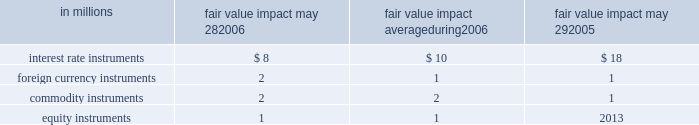Item 7a quantitative and qualitative disclosures about market risk we are exposed to market risk stemming from changes in interest rates , foreign exchange rates , commodity prices and equity prices .
Changes in these factors could cause fluctuations in our earnings and cash flows .
In the normal course of business , we actively manage our exposure to these market risks by entering into various hedging trans- actions , authorized under our policies that place clear controls on these activities .
The counterparties in these transactions are generally highly rated institutions .
We establish credit limits for each counterparty .
Our hedging transactions include but are not limited to a variety of deriv- ative financial instruments .
Interest rates we manage our debt structure and our interest rate risk through the use of fixed- and floating-rate debt and derivatives .
We use interest rate swaps and forward-starting interest rate swaps to hedge our exposure to interest rate changes and to reduce volatility of our financing costs .
Generally under these swaps , we agree with a counterparty to exchange the difference between fixed- rate and floating-rate interest amounts based on an agreed notional principal amount .
Our primary exposure is to u.s .
Interest rates .
As of may 28 , 2006 , we had $ 7.0 billion of aggregate notional principal amount ( the principal amount on which the fixed or floating interest rate is calculated ) outstanding .
This includes notional amounts of offsetting swaps that neutralize our exposure to interest rates on other interest rate swaps .
See note six to the consolidated finan- cial statements on pages 40 through 42 in item eight of this report .
Foreign currency rates foreign currency fluctuations can affect our net investments and earnings denominated in foreign currencies .
We primarily use foreign currency forward contracts and option contracts to selectively hedge our cash flow exposure to changes in exchange rates .
These contracts function as hedges , since they change in value inversely to the change created in the underlying exposure as foreign exchange rates fluctuate .
Our primary u.s .
Dollar exchange rate exposures are with the canadian dollar , the euro , the australian dollar , the mexican peso and the british pound .
Commodities many commodities we use in the produc- tion and distribution of our products are exposed to market price risks .
We manage this market risk through an inte- grated set of financial instruments , including purchase orders , noncancelable contracts , futures contracts , options and swaps .
Our primary commodity price exposures are to cereal grains , sugar , dairy products , vegetables , fruits , meats , vegetable oils , and other agricultural products , as well as paper and plastic packaging materials , operating supplies and energy .
Equity instruments equity price movements affect our compensation expense as certain investments owned by our employees are revalued .
We use equity swaps to manage this market risk .
Value at risk these estimates are intended to measure the maximum potential fair value we could lose in one day from adverse changes in market interest rates , foreign exchange rates , commodity prices , or equity prices under normal market conditions .
A monte carlo ( var ) method- ology was used to quantify the market risk for our exposures .
The models assumed normal market conditions and used a 95 percent confidence level .
The var calculation used historical interest rates , foreign exchange rates and commodity and equity prices from the past year to estimate the potential volatility and correlation of these rates in the future .
The market data were drawn from the riskmetricstm data set .
The calculations are not intended to represent actual losses in fair value that we expect to incur .
Further , since the hedging instrument ( the derivative ) inversely correlates with the underlying expo- sure , we would expect that any loss or gain in the fair value of our derivatives would be generally offset by an increase or decrease in the fair value of the underlying exposures .
The positions included in the calculations were : debt ; invest- ments ; interest rate swaps ; foreign exchange forwards ; commodity swaps , futures and options ; and equity instru- ments .
The calculations do not include the underlying foreign exchange and commodities-related positions that are hedged by these market-risk-sensitive instruments .
The table below presents the estimated maximum poten- tial one-day loss in fair value for our interest rate , foreign currency , commodity and equity market-risk-sensitive instruments outstanding on may 28 , 2006 and may 29 , 2005 , and the average amount outstanding during the year ended may 28 , 2006 .
The amounts were calculated using the var methodology described above. .

What is the total fair value impact of all instruments as of may 28 , 2006? 
Computations: (((8 + 2) + 2) + 1)
Answer: 13.0. 